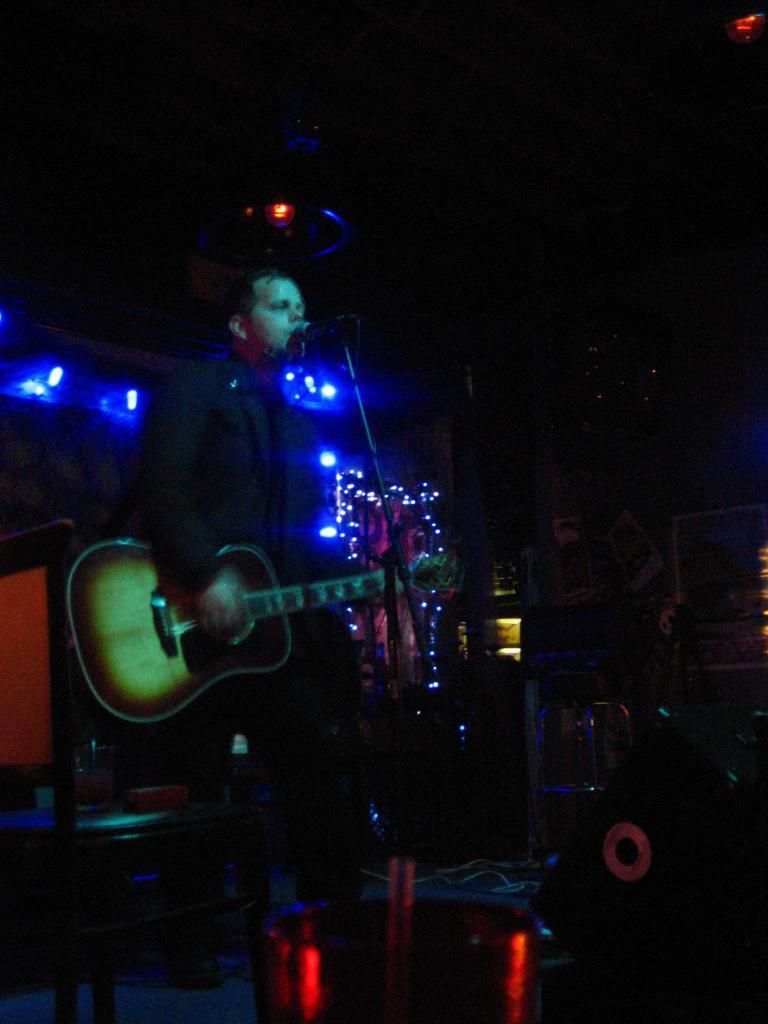Could you give a brief overview of what you see in this image? In this we can see a man playing a guitar and singing with a microphone in front of him and behind him we can see colorful lights 